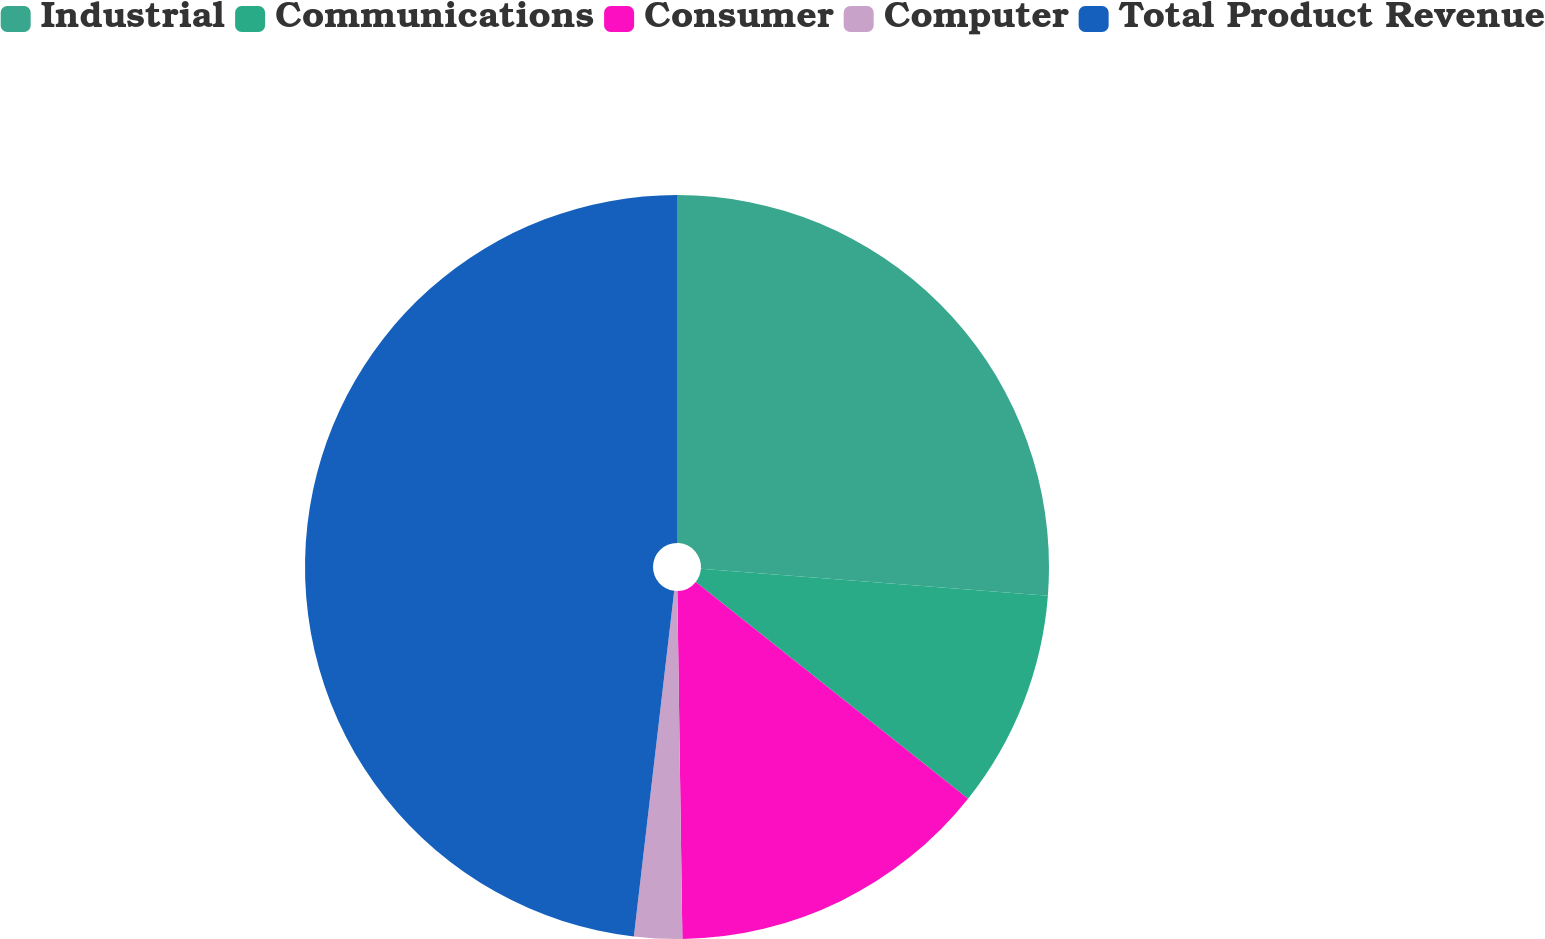<chart> <loc_0><loc_0><loc_500><loc_500><pie_chart><fcel>Industrial<fcel>Communications<fcel>Consumer<fcel>Computer<fcel>Total Product Revenue<nl><fcel>26.23%<fcel>9.47%<fcel>14.07%<fcel>2.08%<fcel>48.15%<nl></chart> 